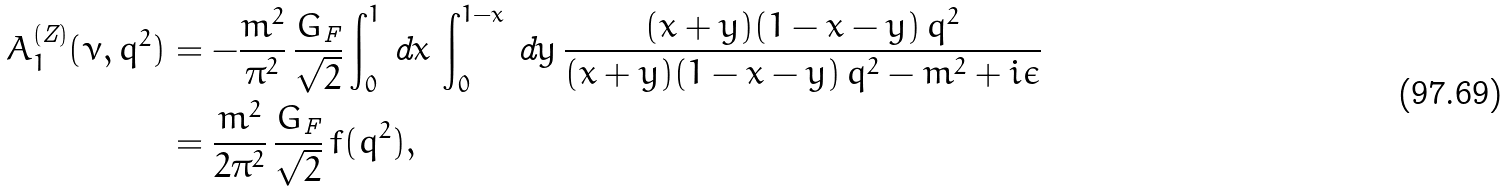Convert formula to latex. <formula><loc_0><loc_0><loc_500><loc_500>A _ { 1 } ^ { ( \text  Z)}(\nu,q^{2})  &= -\frac{m^{2} } { \pi ^ { 2 } } \, \frac { G _ { \text  F}}{\sqrt{2}}\int_{0}^{1}\,\text  dx \,\int_{0}^{1-x}\,\text  dy\,  \frac{(x+y)(1-x-y)\,q^{2}}{(x+y)(1-x-y)\,q^{2}-m^{2}+i\epsilon}\\&=\frac{m^{2}}{2\pi^{2}}\,\frac{G_{\text  F}}{\sqrt{2}}\, f(q^{2}),</formula> 